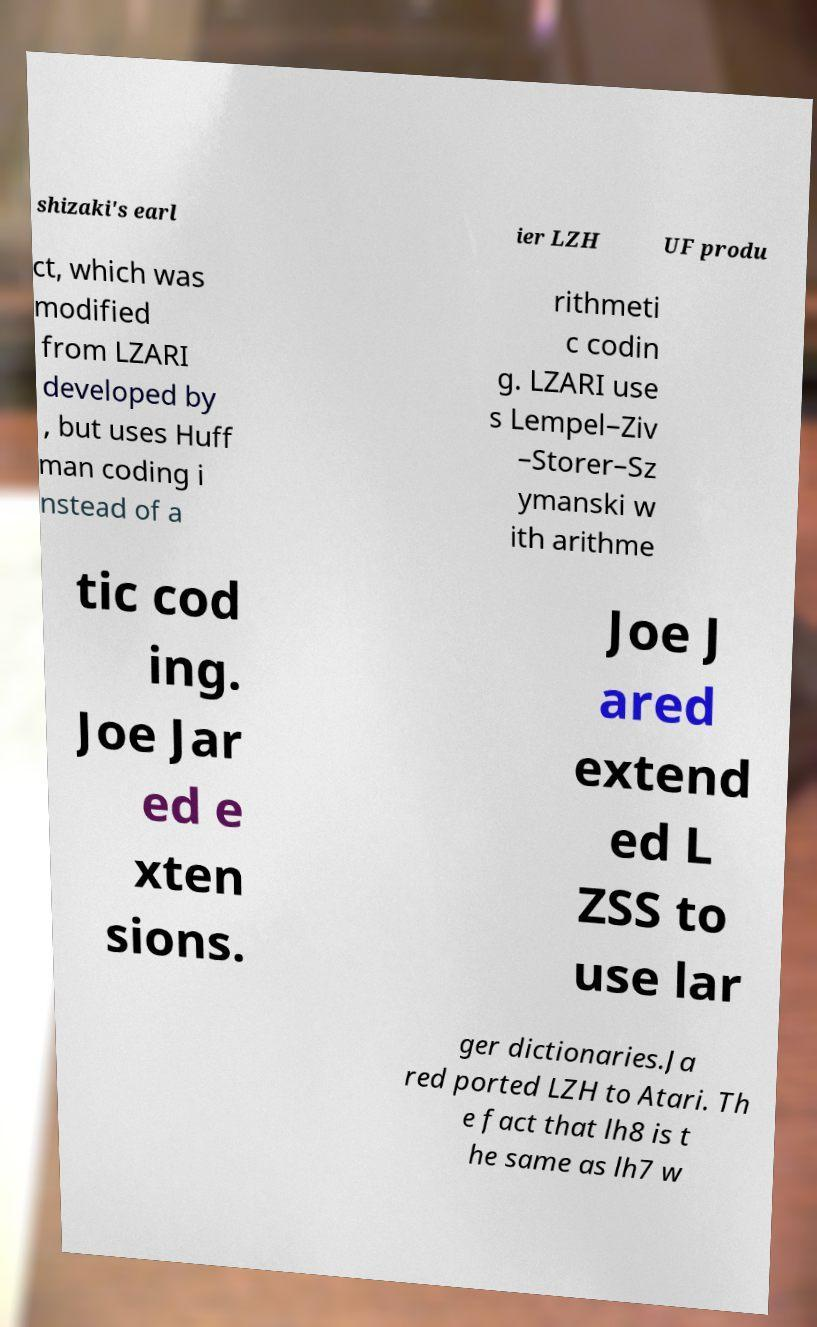Please read and relay the text visible in this image. What does it say? shizaki's earl ier LZH UF produ ct, which was modified from LZARI developed by , but uses Huff man coding i nstead of a rithmeti c codin g. LZARI use s Lempel–Ziv –Storer–Sz ymanski w ith arithme tic cod ing. Joe Jar ed e xten sions. Joe J ared extend ed L ZSS to use lar ger dictionaries.Ja red ported LZH to Atari. Th e fact that lh8 is t he same as lh7 w 